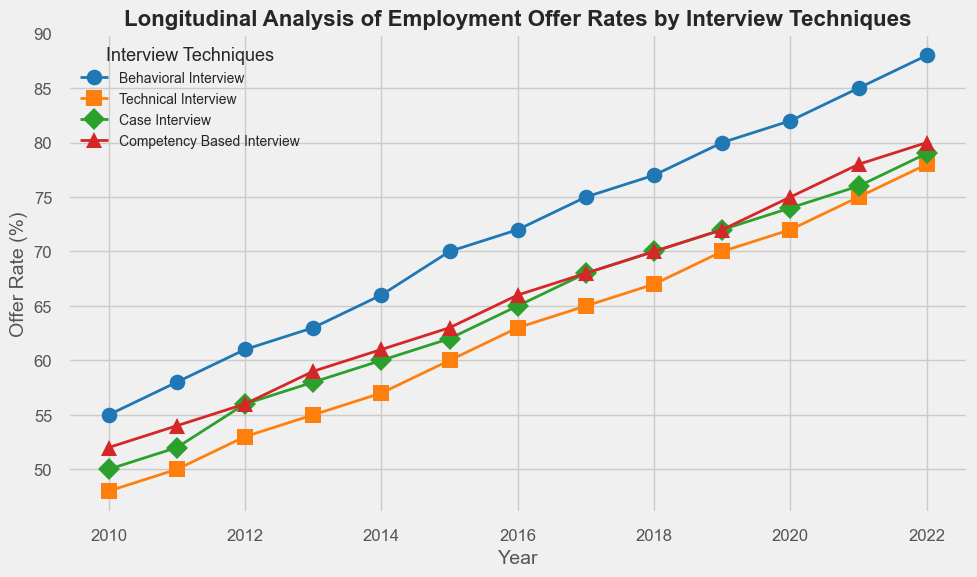What year did the behavioral interview technique have the highest offer rate? Examine the trend for the behavioral interview line and find the highest point, which is at 2022.
Answer: 2022 Comparing 2014, which interview techniques had an offer rate higher than 60%? Look at the 2014 data points for each technique to see which ones are above 60%. Behavioral and Technical interviews both had higher than 60% rates that year.
Answer: Behavioral, Technical What is the average offer rate for the technical interview technique from 2010 to 2022? Sum the offer rates from 2010 to 2022 for the technical interview and then divide by the number of years (13). Sum = 48 + 50 + 53 + 55 + 57 + 60 + 63 + 65 + 67 + 70 + 72 + 75 + 78 = 783. Average = 783 / 13 ≈ 60.23
Answer: 60.23 Which interview technique had the lowest offer rate in 2010, and how much was it? Look at the data points for all techniques in 2010, the lowest is the Technical interview with 48%.
Answer: Technical, 48% By what percentage did the offer rate for the competency-based interview increase from 2010 to 2022? Calculate the percentage increase from 2010 (52%) to 2022 (80%). The increase is 80 - 52 = 28%.
Answer: 28% In which year did all interview techniques first exceed a 60% offer rate? Identify the year when all techniques' lines are above 60%. This first occurs in 2016.
Answer: 2016 Which interview technique showed the most consistent growth in offer rates over the years? Analyze the trend lines for each technique and determine the one with the most steady incline, the Competency-based interview shows consistent and steady growth.
Answer: Competency-based What is the difference in offer rates for the case interview technique between 2012 and 2018? Find the difference between 2018 (70%) and 2012 (56%). The difference is 70 - 56 = 14%.
Answer: 14% Which two interview techniques had converging trajectories in the latter years of the data? Examine the trends towards the end of the timeline and notice that Competency-based and Technical interview techniques converge closely.
Answer: Competency-based, Technical What was the offer rate trend for the behavioral interview from 2010 to 2015? Review the increase trajectory from 55% in 2010 to 70% in 2015, showing a steady incline each year.
Answer: Steady increase 